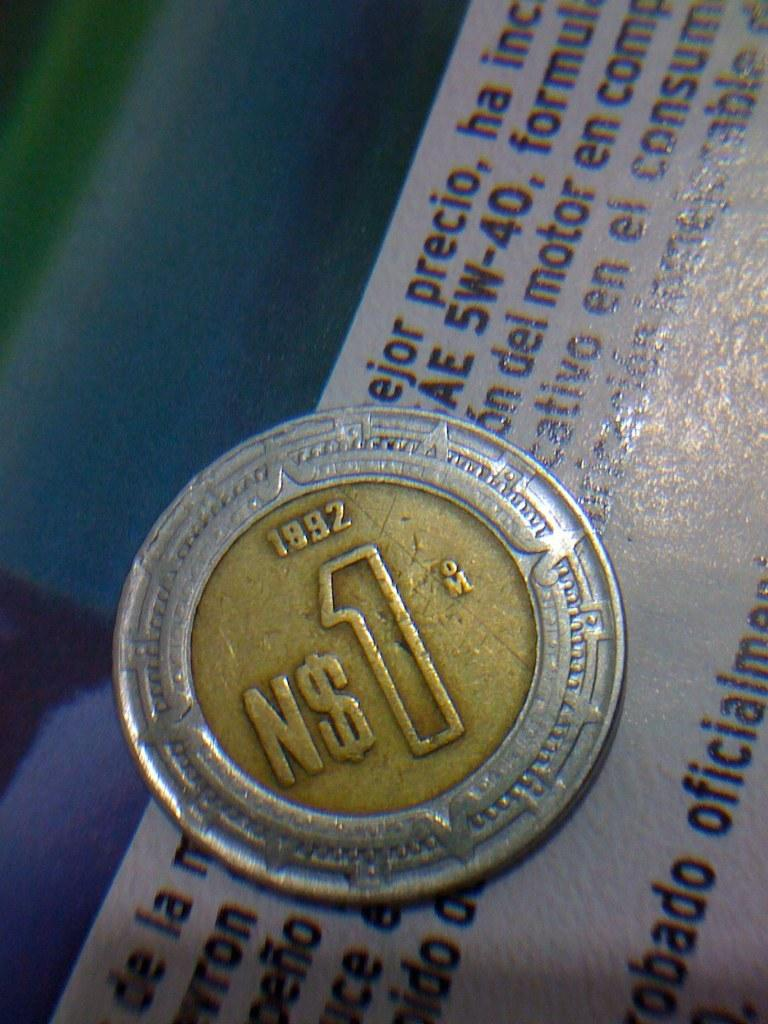<image>
Describe the image concisely. a gold coin with a silver border that reads 'N$1' 